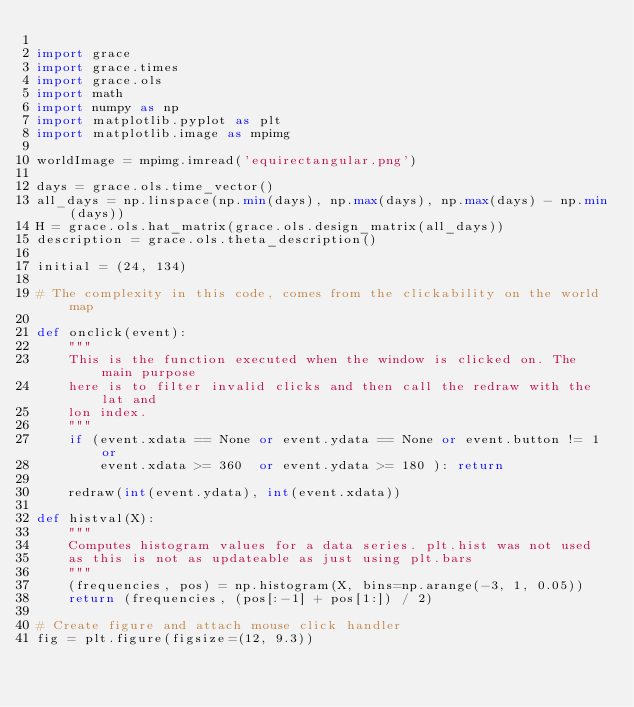<code> <loc_0><loc_0><loc_500><loc_500><_Python_>
import grace
import grace.times
import grace.ols
import math
import numpy as np
import matplotlib.pyplot as plt
import matplotlib.image as mpimg

worldImage = mpimg.imread('equirectangular.png')

days = grace.ols.time_vector()
all_days = np.linspace(np.min(days), np.max(days), np.max(days) - np.min(days))
H = grace.ols.hat_matrix(grace.ols.design_matrix(all_days))
description = grace.ols.theta_description()

initial = (24, 134)

# The complexity in this code, comes from the clickability on the world map

def onclick(event):
	"""
	This is the function executed when the window is clicked on. The main purpose
	here is to filter invalid clicks and then call the redraw with the lat and
	lon index.
	"""
	if (event.xdata == None or event.ydata == None or event.button != 1 or
		event.xdata >= 360  or event.ydata >= 180 ): return

	redraw(int(event.ydata), int(event.xdata))

def histval(X):
	"""
	Computes histogram values for a data series. plt.hist was not used
	as this is not as updateable as just using plt.bars
	"""
	(frequencies, pos) = np.histogram(X, bins=np.arange(-3, 1, 0.05))
	return (frequencies, (pos[:-1] + pos[1:]) / 2)

# Create figure and attach mouse click handler
fig = plt.figure(figsize=(12, 9.3))</code> 